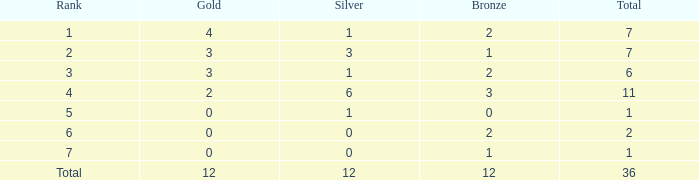What is the largest total for a team with 1 bronze, 0 gold medals and ranking of 7? None. 